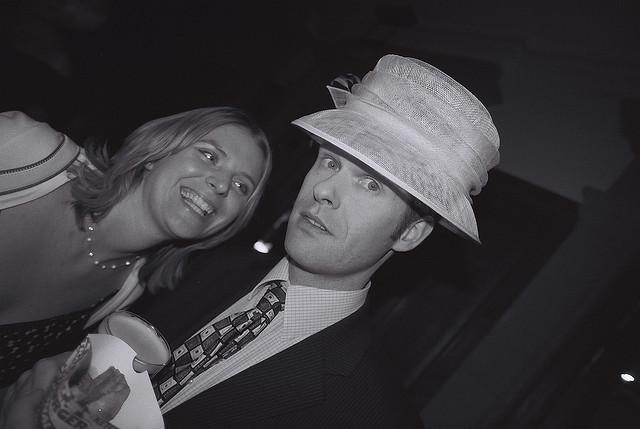What does he have on his head?
Quick response, please. Hat. What is the around the man's neck?
Quick response, please. Tie. Are these people a  couple?
Concise answer only. Yes. Is that a hat made for women?
Answer briefly. Yes. How many hats?
Be succinct. 1. Is the woman single?
Concise answer only. No. Is this woman upset?
Write a very short answer. No. Is she all covered?
Keep it brief. No. Does the girl have long hair?
Short answer required. No. What color is the woman's hair?
Keep it brief. Blonde. What is the girl looking at?
Short answer required. Man. How many people are in the photo?
Short answer required. 2. 